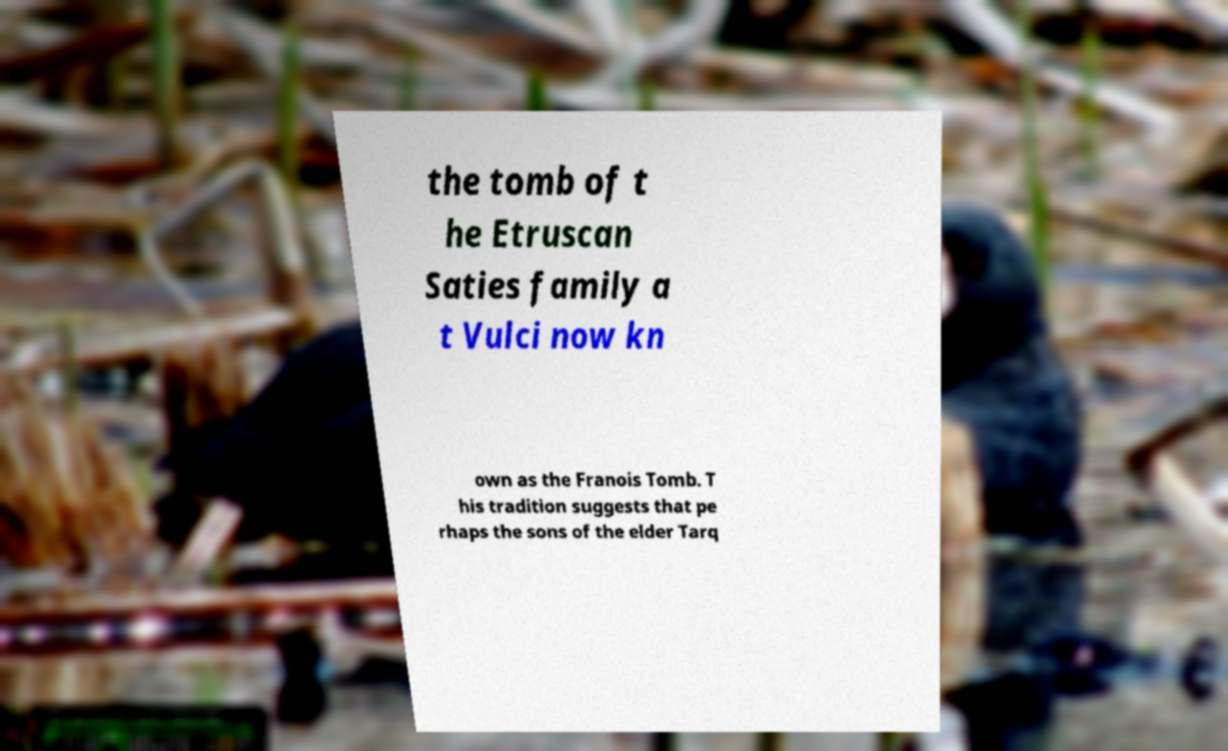Please read and relay the text visible in this image. What does it say? the tomb of t he Etruscan Saties family a t Vulci now kn own as the Franois Tomb. T his tradition suggests that pe rhaps the sons of the elder Tarq 